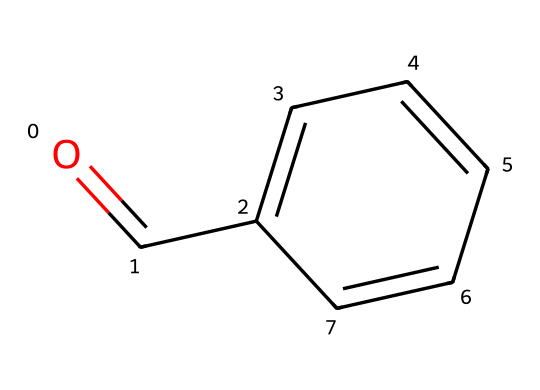What is the functional group present in benzaldehyde? The SMILES notation indicates a carbonyl group (C=O) attached to a carbon that is part of an aromatic ring. This identifies benzaldehyde as containing an aldehyde functional group.
Answer: aldehyde How many carbon atoms are in benzaldehyde? Analyzing the structure shows that there are six carbon atoms in the benzene ring and one carbon from the aldehyde functional group, totaling seven carbon atoms.
Answer: 7 What type of smell is benzaldehyde commonly associated with? Benzaldehyde is known for its characteristic almond scent, which is commonly used in personal care products like lotions and perfumes.
Answer: almond What is the molecular formula of benzaldehyde? The structure includes six carbon atoms, five hydrogen atoms, and one oxygen atom, leading to the molecular formula C7H6O.
Answer: C7H6O Does benzaldehyde engage in hydrogen bonding? Benzaldehyde has an oxygen atom in the carbonyl group, which can form hydrogen bonds; however, the presence of only one hydrogen atom bonded to the carbon in the aldehyde limits its ability to form extensive hydrogen bonds.
Answer: limited What type of compound is benzaldehyde classified as? Given that benzaldehyde contains a carbonyl group attached to an aromatic ring, it belongs to the class of compounds known as aromatic aldehydes.
Answer: aromatic aldehyde 